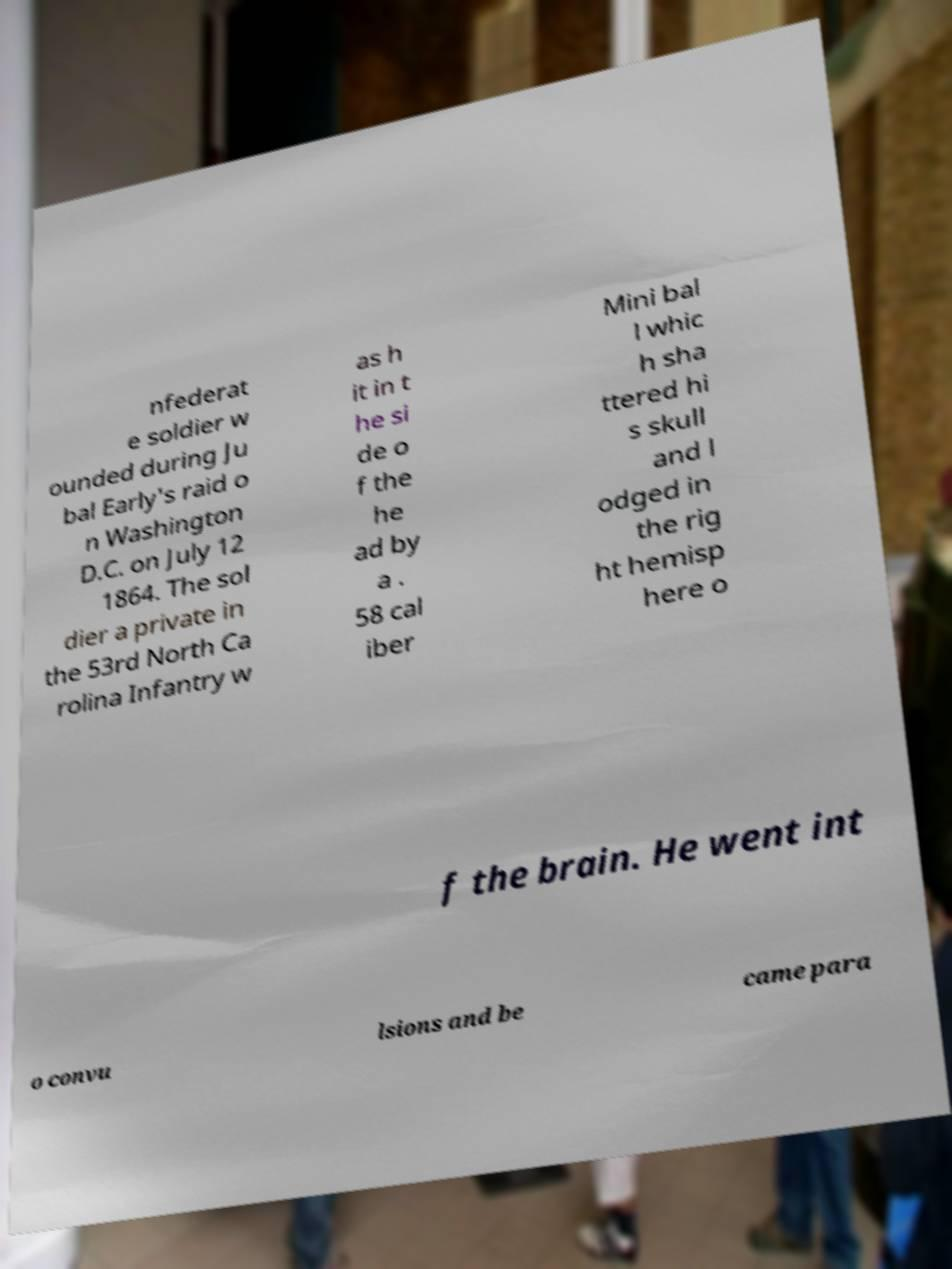Could you extract and type out the text from this image? nfederat e soldier w ounded during Ju bal Early's raid o n Washington D.C. on July 12 1864. The sol dier a private in the 53rd North Ca rolina Infantry w as h it in t he si de o f the he ad by a . 58 cal iber Mini bal l whic h sha ttered hi s skull and l odged in the rig ht hemisp here o f the brain. He went int o convu lsions and be came para 